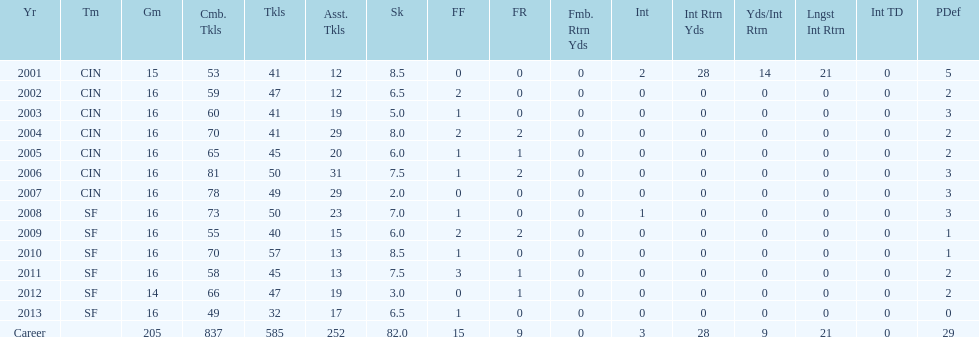How many sacks did this player have in his first five seasons? 34. 